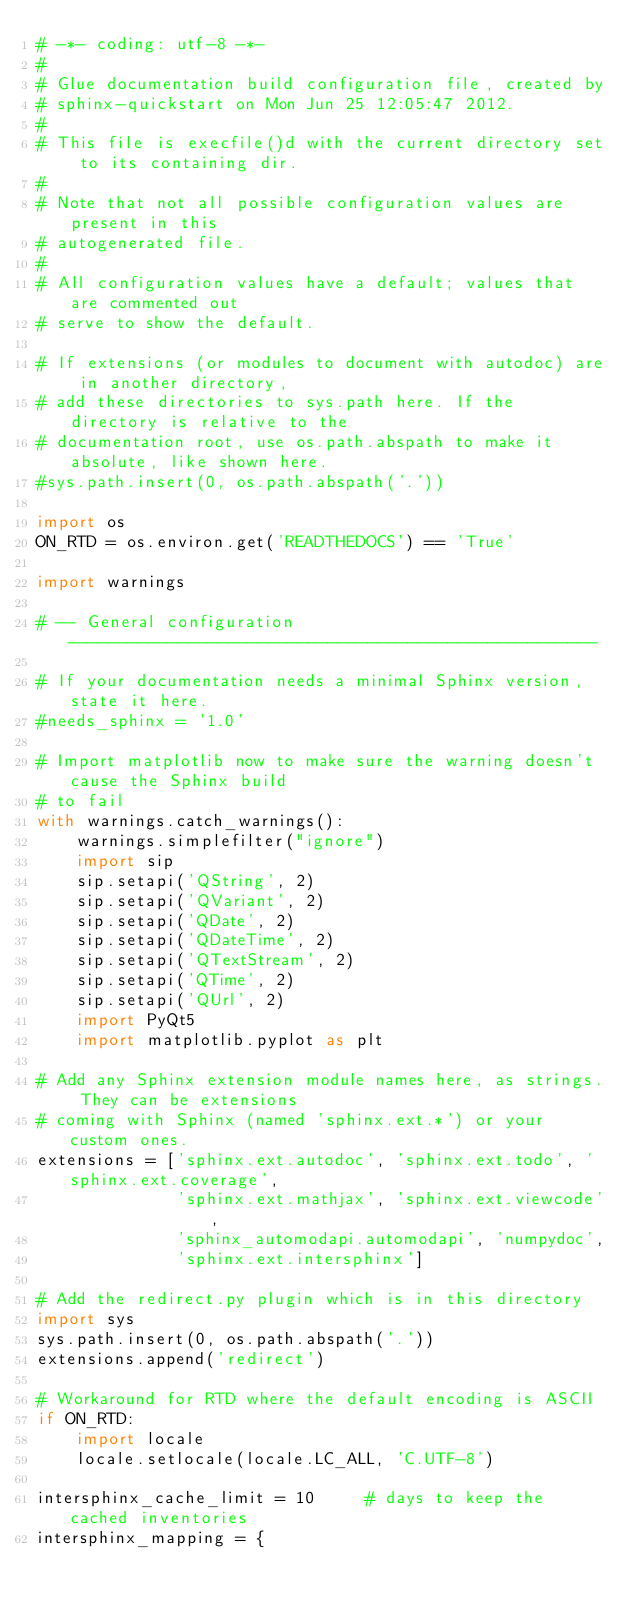Convert code to text. <code><loc_0><loc_0><loc_500><loc_500><_Python_># -*- coding: utf-8 -*-
#
# Glue documentation build configuration file, created by
# sphinx-quickstart on Mon Jun 25 12:05:47 2012.
#
# This file is execfile()d with the current directory set to its containing dir.
#
# Note that not all possible configuration values are present in this
# autogenerated file.
#
# All configuration values have a default; values that are commented out
# serve to show the default.

# If extensions (or modules to document with autodoc) are in another directory,
# add these directories to sys.path here. If the directory is relative to the
# documentation root, use os.path.abspath to make it absolute, like shown here.
#sys.path.insert(0, os.path.abspath('.'))

import os
ON_RTD = os.environ.get('READTHEDOCS') == 'True'

import warnings

# -- General configuration -----------------------------------------------------

# If your documentation needs a minimal Sphinx version, state it here.
#needs_sphinx = '1.0'

# Import matplotlib now to make sure the warning doesn't cause the Sphinx build
# to fail
with warnings.catch_warnings():
    warnings.simplefilter("ignore")
    import sip
    sip.setapi('QString', 2)
    sip.setapi('QVariant', 2)
    sip.setapi('QDate', 2)
    sip.setapi('QDateTime', 2)
    sip.setapi('QTextStream', 2)
    sip.setapi('QTime', 2)
    sip.setapi('QUrl', 2)
    import PyQt5
    import matplotlib.pyplot as plt

# Add any Sphinx extension module names here, as strings. They can be extensions
# coming with Sphinx (named 'sphinx.ext.*') or your custom ones.
extensions = ['sphinx.ext.autodoc', 'sphinx.ext.todo', 'sphinx.ext.coverage',
              'sphinx.ext.mathjax', 'sphinx.ext.viewcode',
              'sphinx_automodapi.automodapi', 'numpydoc',
              'sphinx.ext.intersphinx']

# Add the redirect.py plugin which is in this directory
import sys
sys.path.insert(0, os.path.abspath('.'))
extensions.append('redirect')

# Workaround for RTD where the default encoding is ASCII
if ON_RTD:
    import locale
    locale.setlocale(locale.LC_ALL, 'C.UTF-8')

intersphinx_cache_limit = 10     # days to keep the cached inventories
intersphinx_mapping = {</code> 